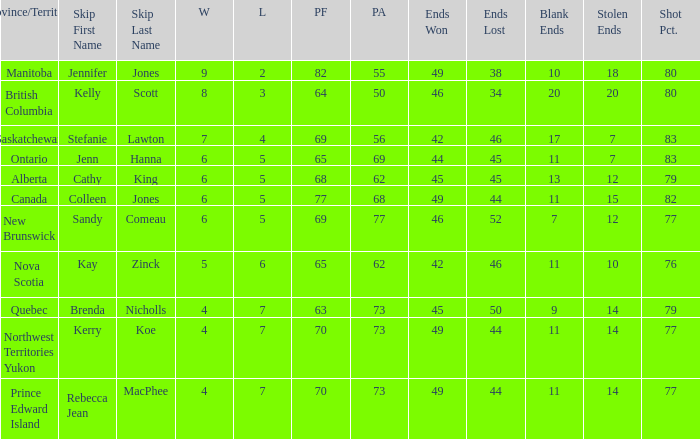What is the PA when the PF is 77? 68.0. 